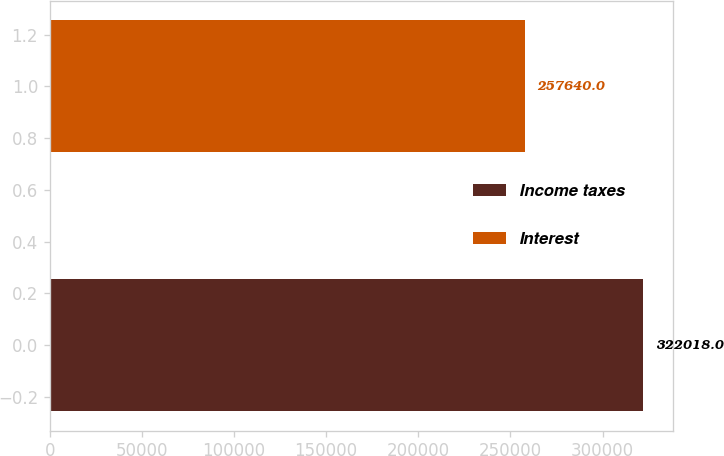Convert chart. <chart><loc_0><loc_0><loc_500><loc_500><bar_chart><fcel>Income taxes<fcel>Interest<nl><fcel>322018<fcel>257640<nl></chart> 